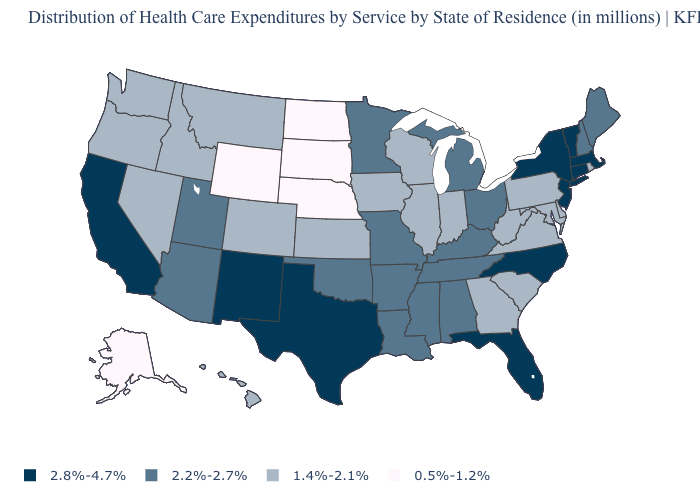Name the states that have a value in the range 2.8%-4.7%?
Quick response, please. California, Connecticut, Florida, Massachusetts, New Jersey, New Mexico, New York, North Carolina, Texas, Vermont. What is the value of Nevada?
Be succinct. 1.4%-2.1%. What is the value of North Dakota?
Answer briefly. 0.5%-1.2%. What is the value of Massachusetts?
Write a very short answer. 2.8%-4.7%. What is the value of Arkansas?
Concise answer only. 2.2%-2.7%. What is the value of Oklahoma?
Give a very brief answer. 2.2%-2.7%. What is the lowest value in the USA?
Be succinct. 0.5%-1.2%. How many symbols are there in the legend?
Concise answer only. 4. Name the states that have a value in the range 1.4%-2.1%?
Answer briefly. Colorado, Delaware, Georgia, Hawaii, Idaho, Illinois, Indiana, Iowa, Kansas, Maryland, Montana, Nevada, Oregon, Pennsylvania, Rhode Island, South Carolina, Virginia, Washington, West Virginia, Wisconsin. Among the states that border Pennsylvania , which have the lowest value?
Give a very brief answer. Delaware, Maryland, West Virginia. What is the lowest value in the USA?
Keep it brief. 0.5%-1.2%. Among the states that border Massachusetts , which have the lowest value?
Keep it brief. Rhode Island. What is the highest value in the South ?
Keep it brief. 2.8%-4.7%. Does Arkansas have a higher value than Utah?
Quick response, please. No. What is the value of Ohio?
Be succinct. 2.2%-2.7%. 